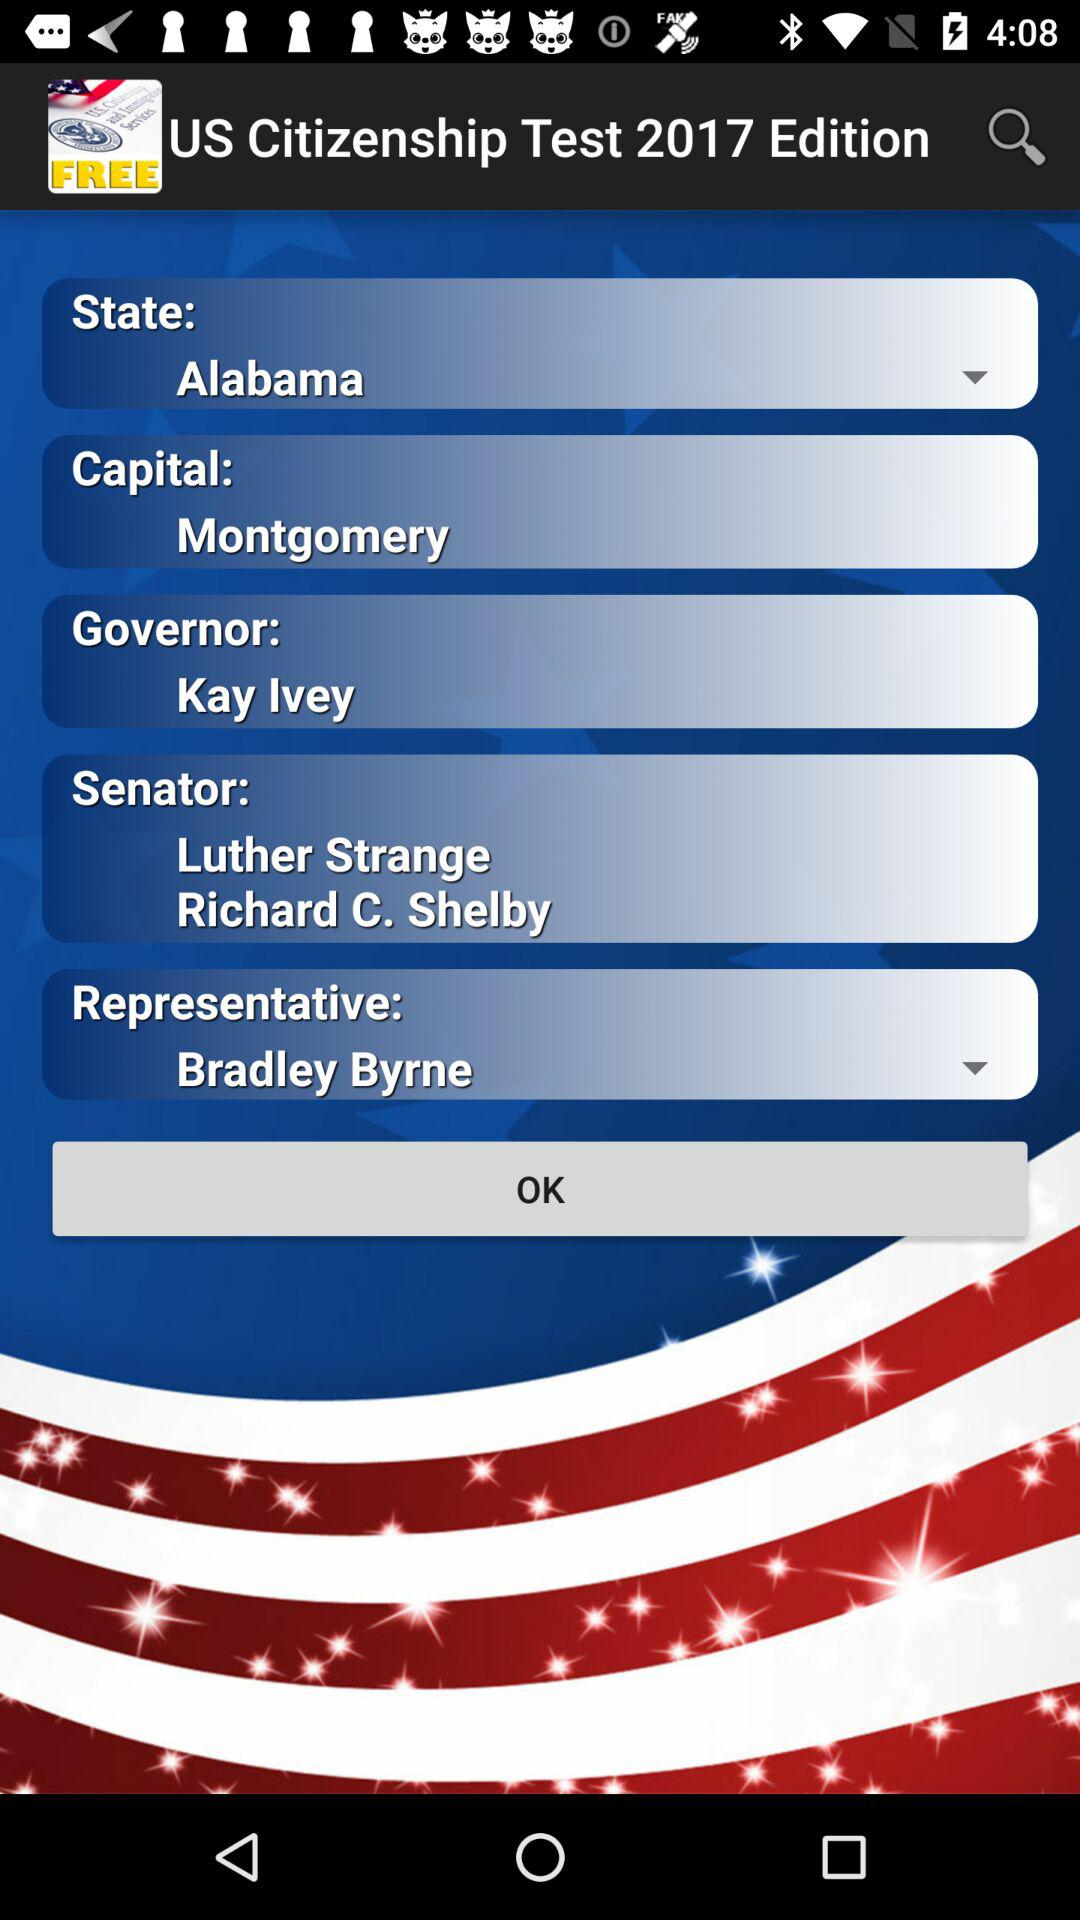Who are the senators? The senators are Luther Strange and Richard C. Shelby. 